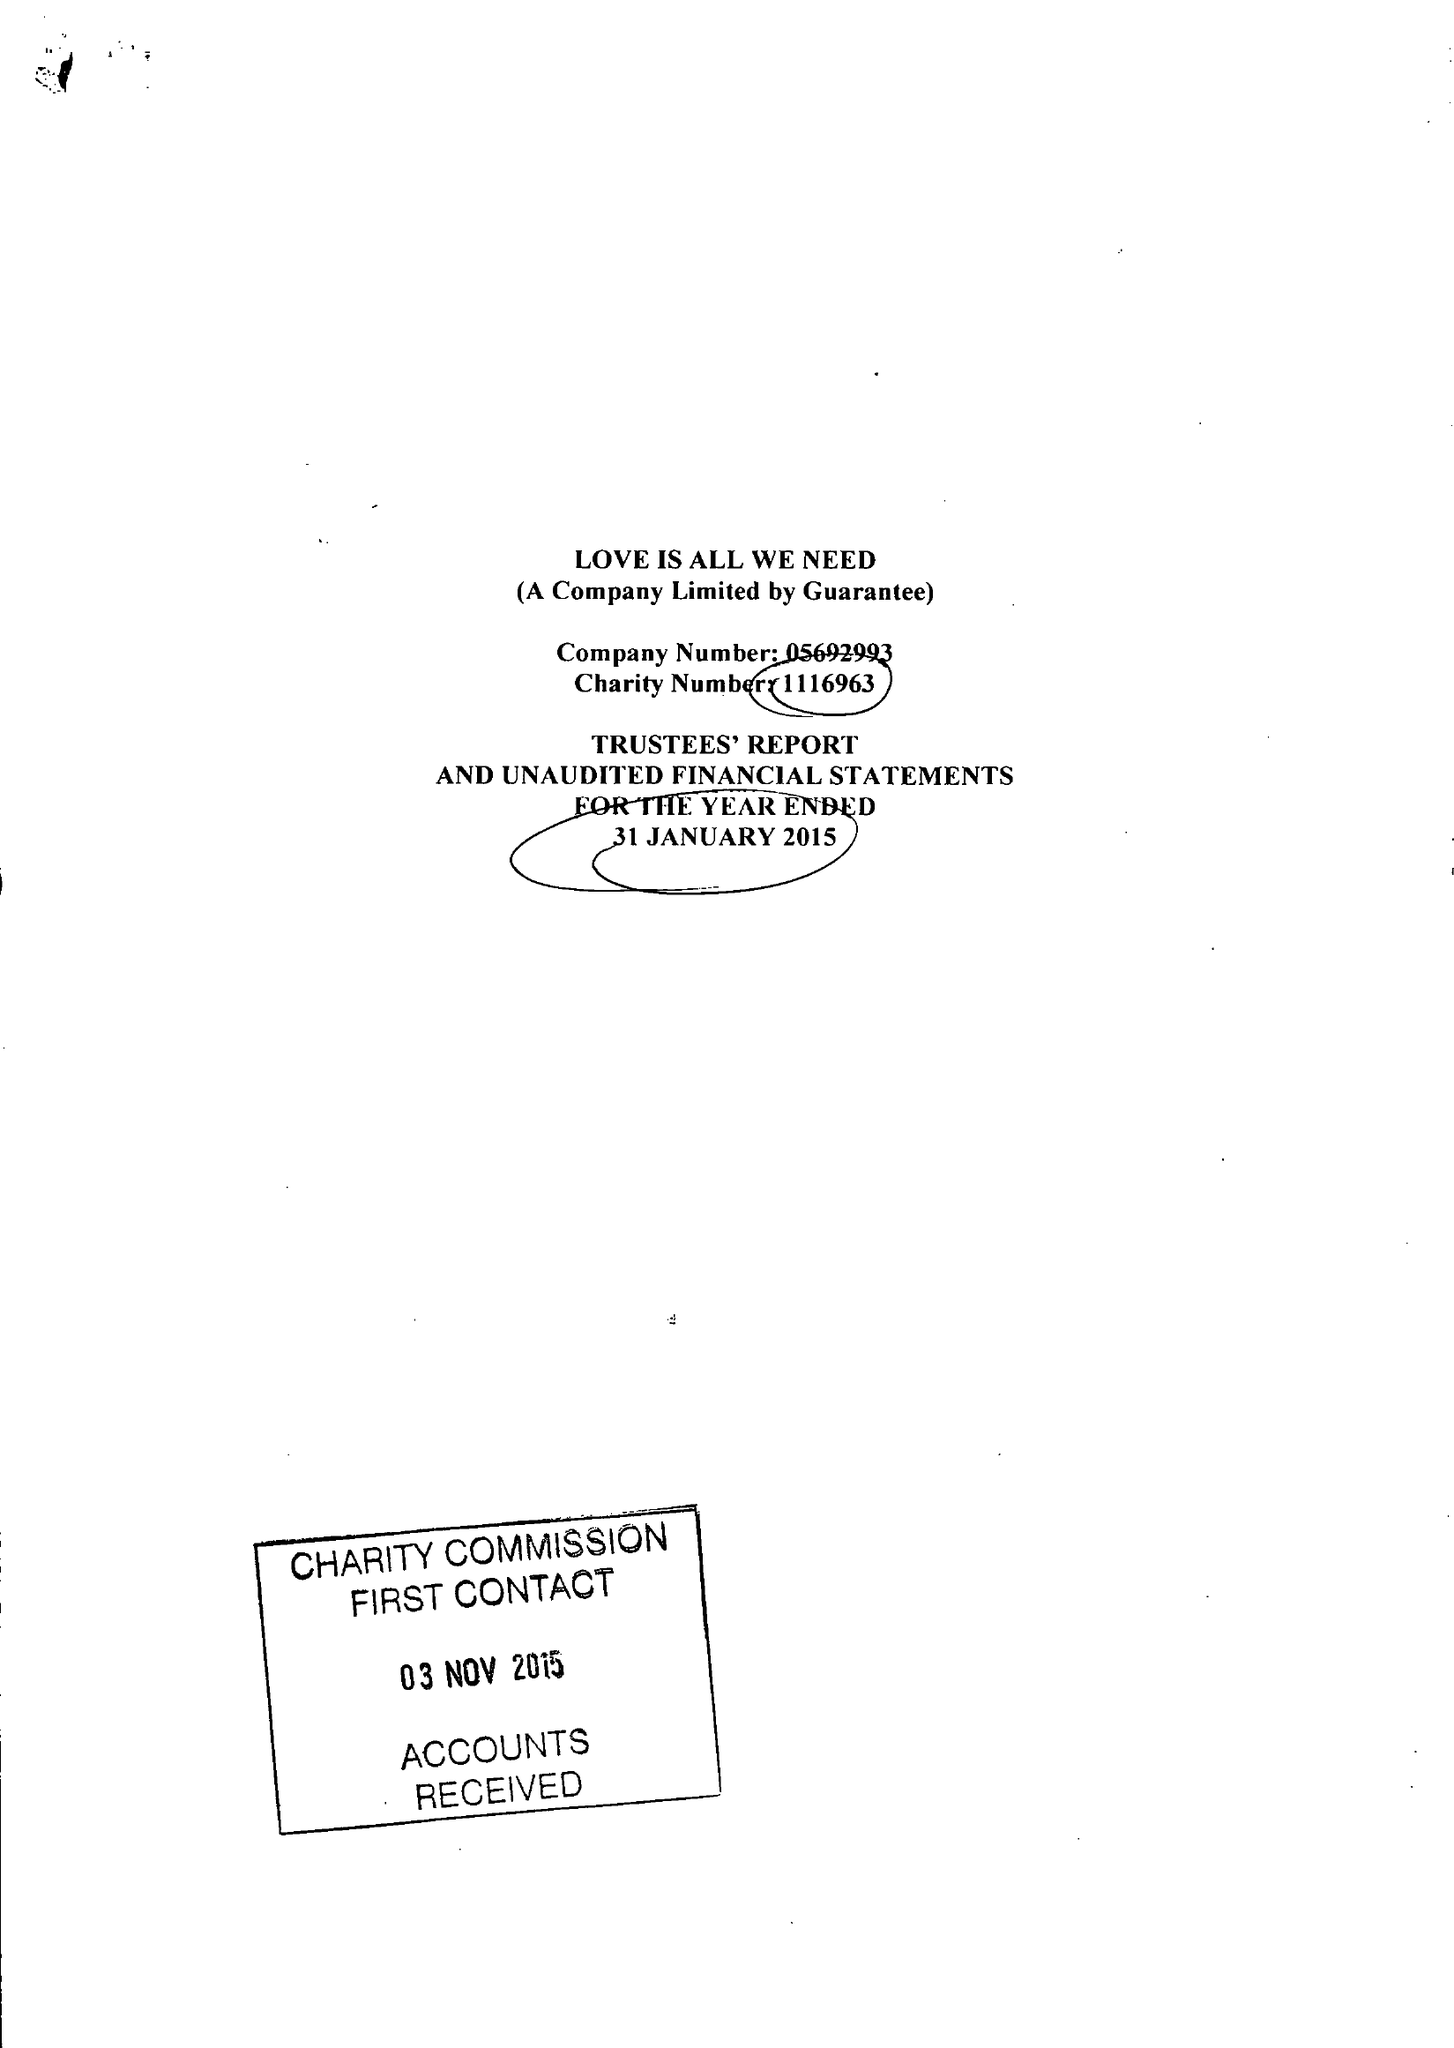What is the value for the address__street_line?
Answer the question using a single word or phrase. 43 WALSINGHAM ROAD 